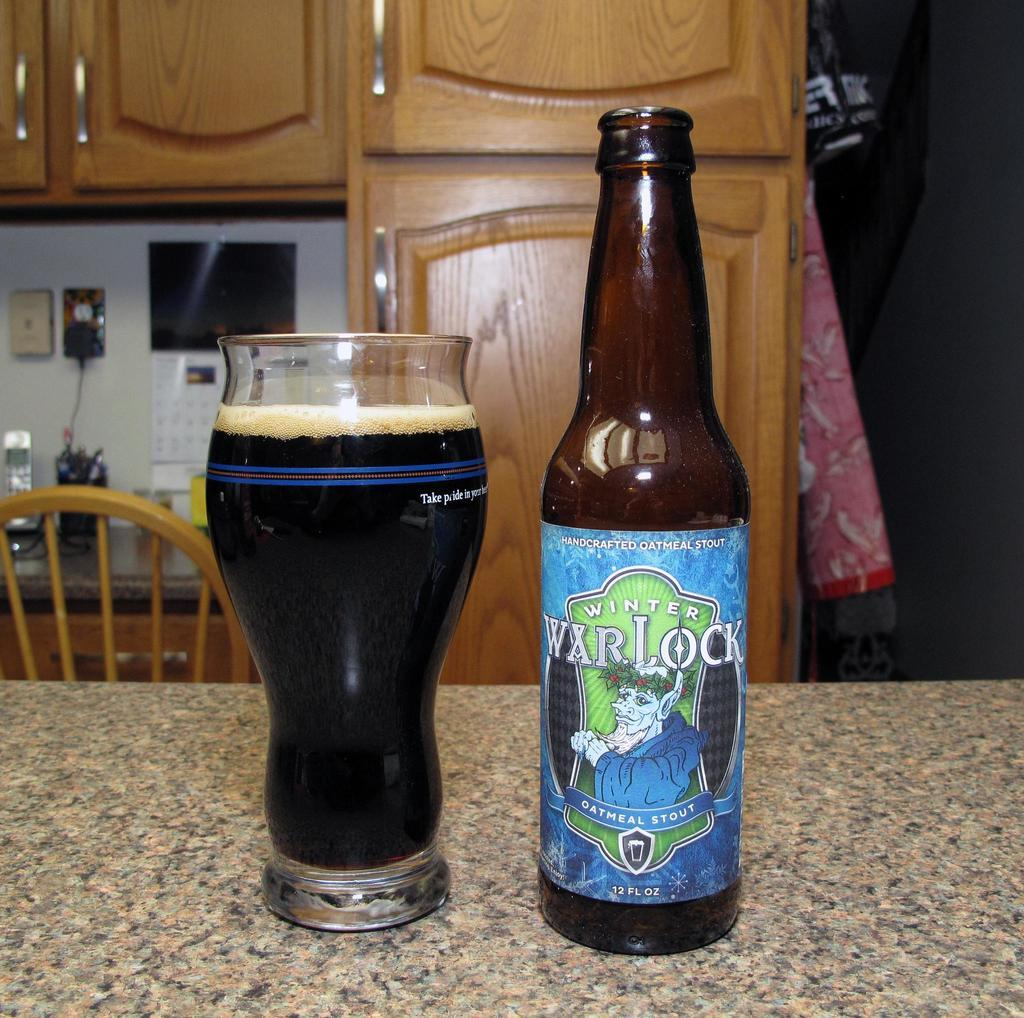<image>
Give a short and clear explanation of the subsequent image. A bottle of Winter Warlack oatmeal stout sits on a counter next to a full glass of it. 